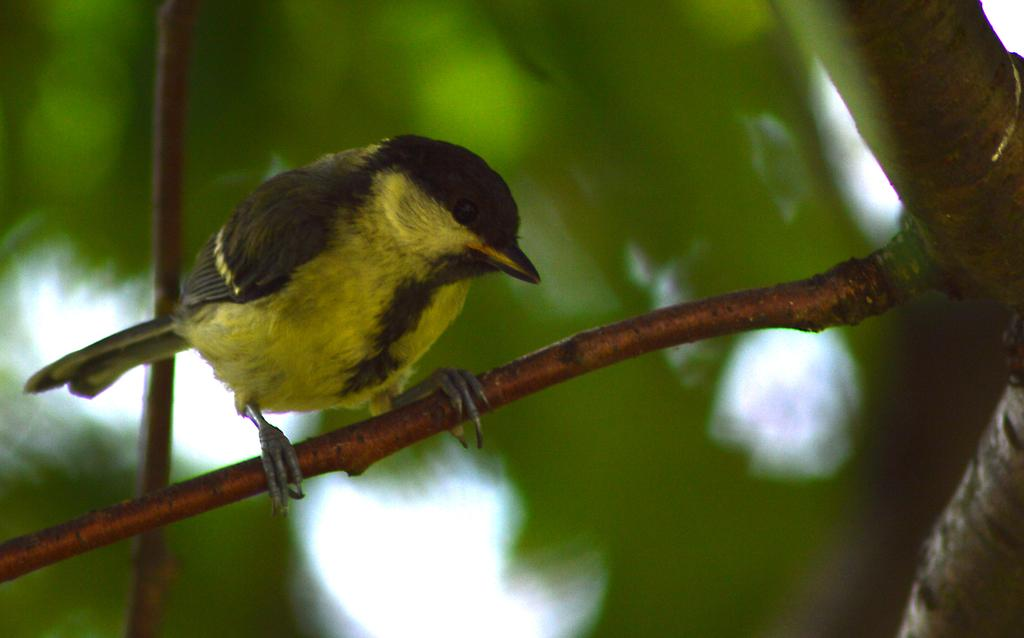What type of animal can be seen in the image? There is a bird in the image. Where is the bird located in the image? The bird is standing on a branch of a tree. Which side of the image does the branch appear on? The branch of the tree is on the left side of the image. How would you describe the background of the image? The background of the image is blurred. What type of art can be seen on the bird's arm in the image? There is no art or arm present on the bird in the image. 